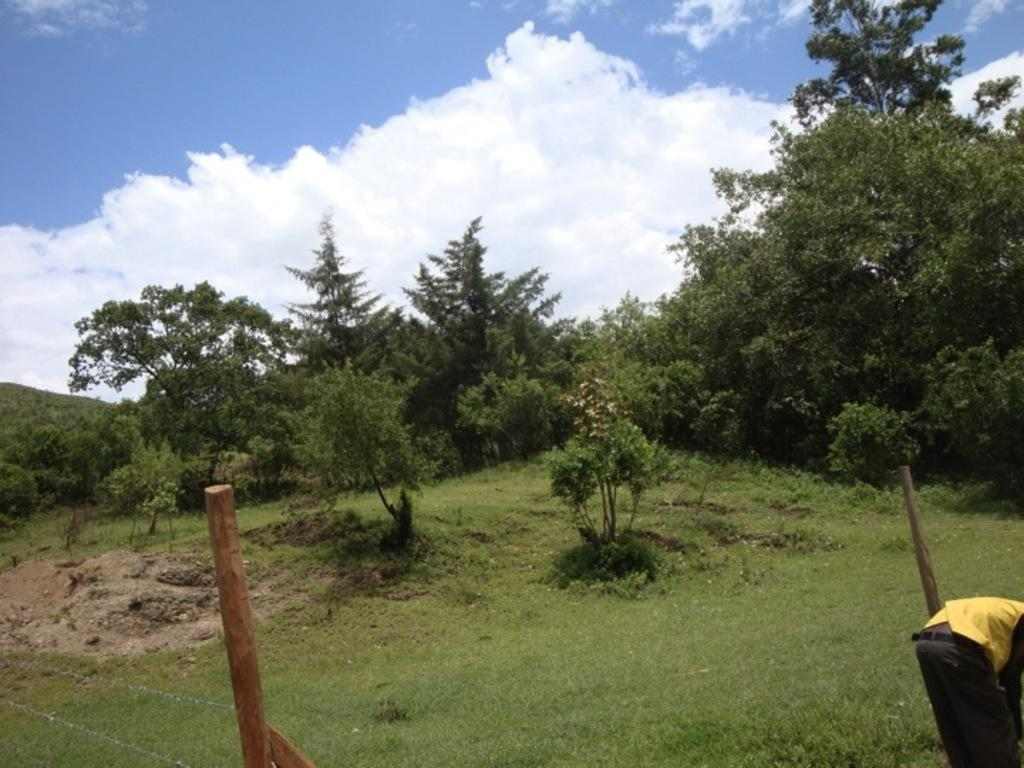What can be seen in the left bottom of the image? There is a fence in the left bottom of the image. What is happening in the right bottom of the image? There is a person standing on the grassland in the right bottom of the image. What type of vegetation is present on the grassland? There are plants and trees on the grassland. What is visible at the top of the image? The sky is visible at the top of the image. What can be observed in the sky? There are clouds in the sky. How many potatoes are being folded by the person in the image? There are no potatoes or folding activity present in the image. What act is the person performing in the image? The person is standing on the grassland, but there is no specific act being performed. 